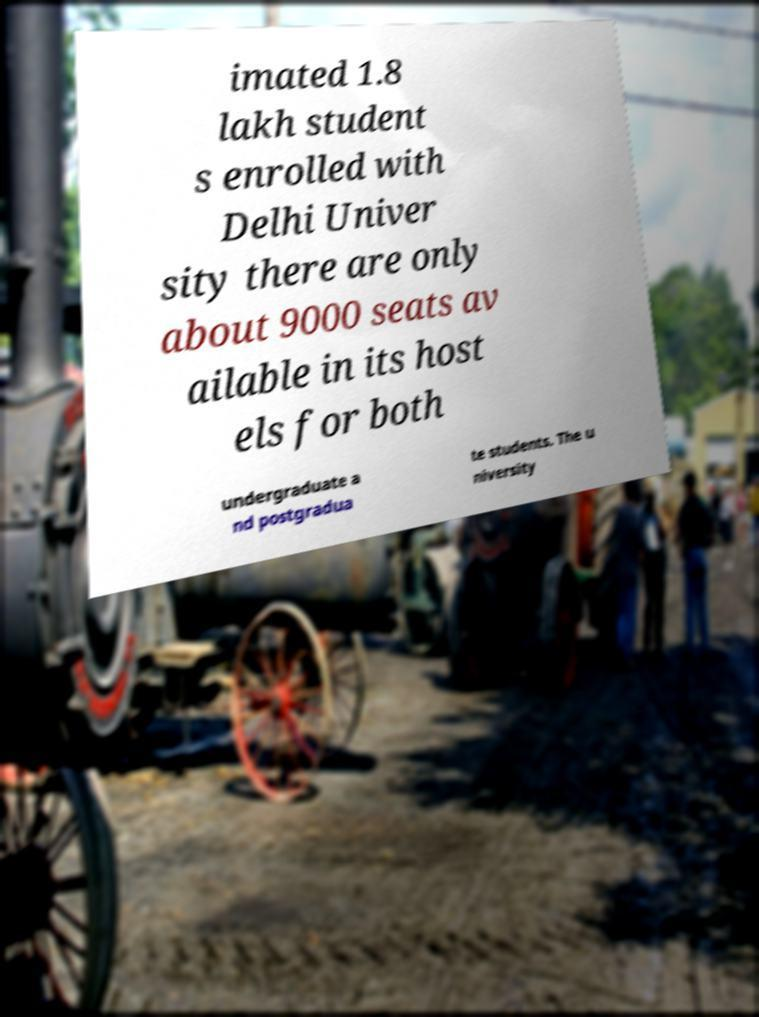There's text embedded in this image that I need extracted. Can you transcribe it verbatim? imated 1.8 lakh student s enrolled with Delhi Univer sity there are only about 9000 seats av ailable in its host els for both undergraduate a nd postgradua te students. The u niversity 